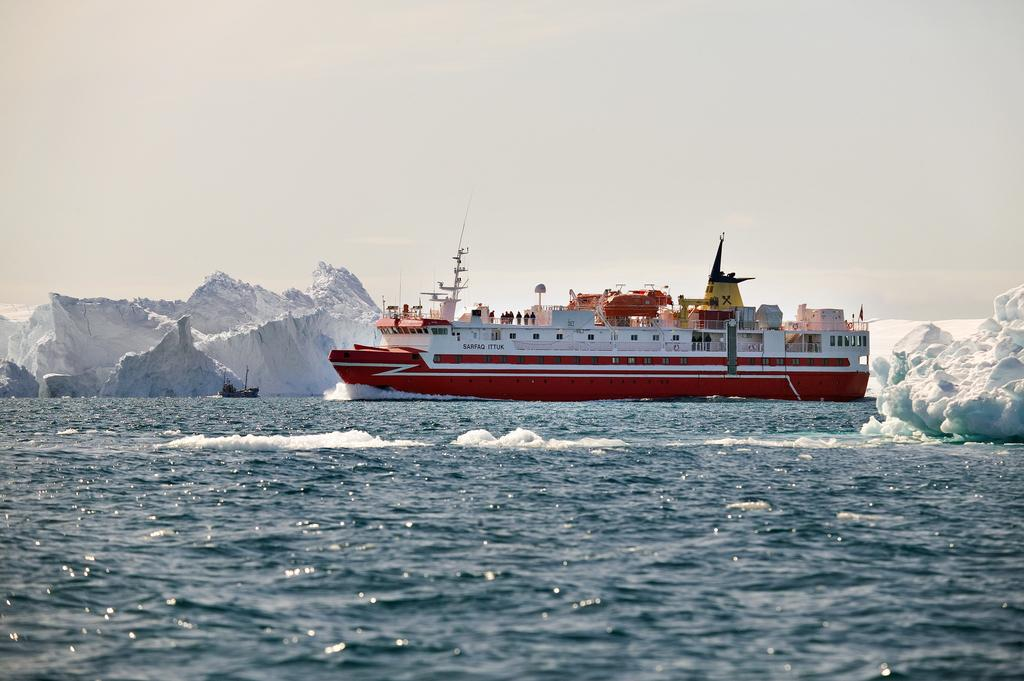What is the main subject of the image? The main subject of the image is a ship. Where is the ship located? The ship is on the water. What can be seen on either side of the ship? There are icebergs on either side of the ship. What type of observation can be made about the branch in the image? There is no branch present in the image. 